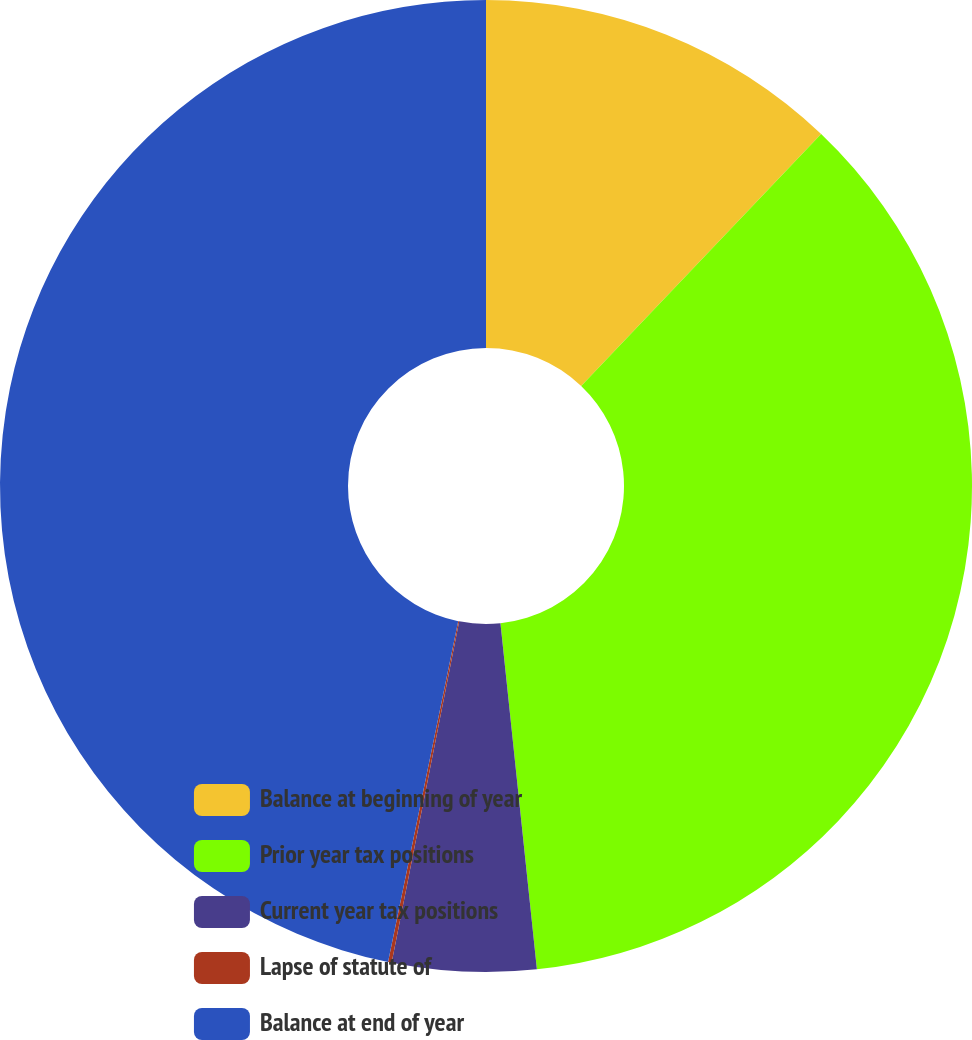Convert chart to OTSL. <chart><loc_0><loc_0><loc_500><loc_500><pie_chart><fcel>Balance at beginning of year<fcel>Prior year tax positions<fcel>Current year tax positions<fcel>Lapse of statute of<fcel>Balance at end of year<nl><fcel>12.11%<fcel>36.22%<fcel>4.78%<fcel>0.12%<fcel>46.77%<nl></chart> 